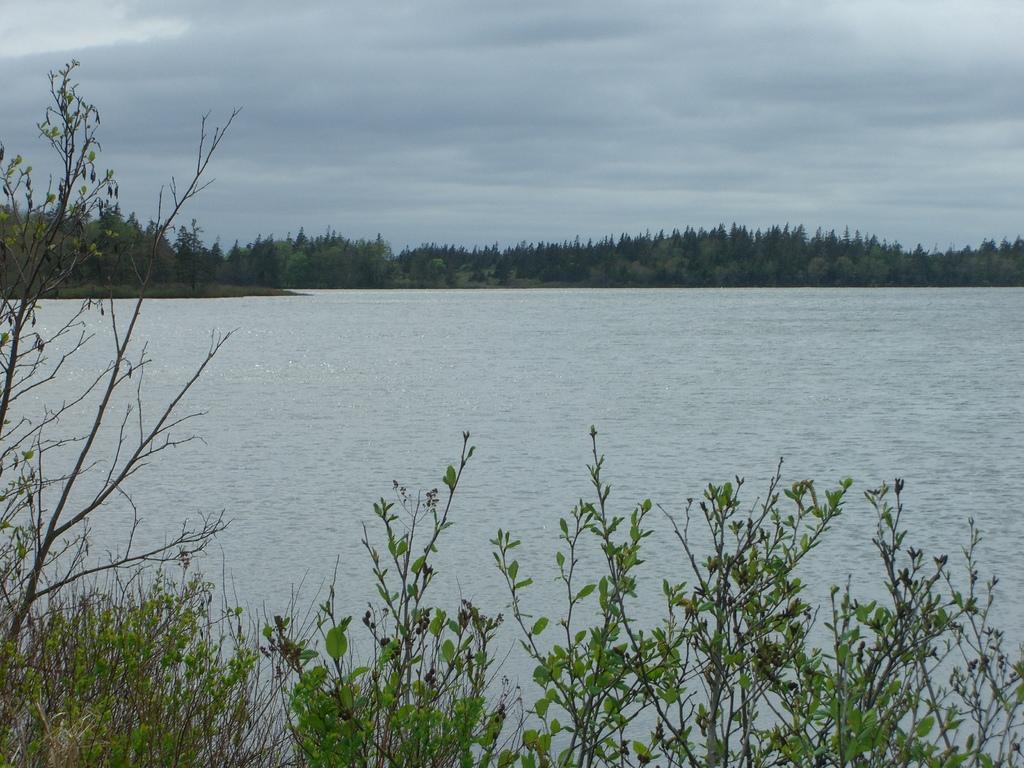Describe this image in one or two sentences. In this image we can see water, trees, plants, sky and clouds. 